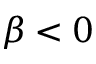<formula> <loc_0><loc_0><loc_500><loc_500>\beta < 0</formula> 